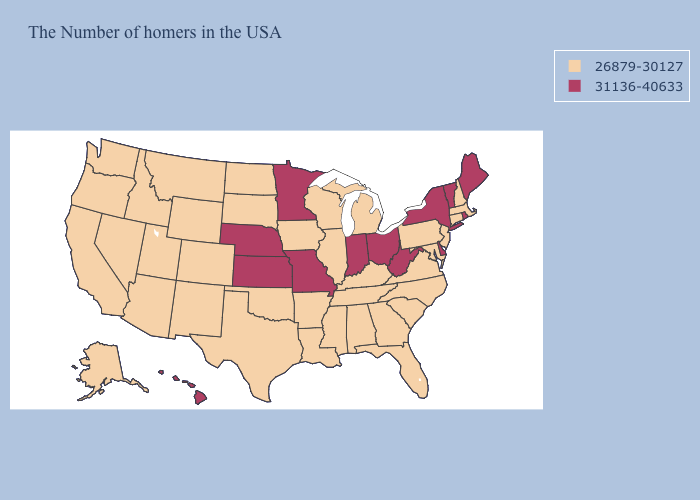Which states have the lowest value in the USA?
Be succinct. Massachusetts, New Hampshire, Connecticut, New Jersey, Maryland, Pennsylvania, Virginia, North Carolina, South Carolina, Florida, Georgia, Michigan, Kentucky, Alabama, Tennessee, Wisconsin, Illinois, Mississippi, Louisiana, Arkansas, Iowa, Oklahoma, Texas, South Dakota, North Dakota, Wyoming, Colorado, New Mexico, Utah, Montana, Arizona, Idaho, Nevada, California, Washington, Oregon, Alaska. What is the highest value in the MidWest ?
Write a very short answer. 31136-40633. Name the states that have a value in the range 31136-40633?
Give a very brief answer. Maine, Rhode Island, Vermont, New York, Delaware, West Virginia, Ohio, Indiana, Missouri, Minnesota, Kansas, Nebraska, Hawaii. What is the value of Indiana?
Short answer required. 31136-40633. What is the highest value in the USA?
Write a very short answer. 31136-40633. Does the map have missing data?
Concise answer only. No. Does Rhode Island have the lowest value in the Northeast?
Be succinct. No. What is the value of Wyoming?
Answer briefly. 26879-30127. Does Nebraska have a lower value than California?
Concise answer only. No. Name the states that have a value in the range 31136-40633?
Keep it brief. Maine, Rhode Island, Vermont, New York, Delaware, West Virginia, Ohio, Indiana, Missouri, Minnesota, Kansas, Nebraska, Hawaii. What is the value of Wyoming?
Keep it brief. 26879-30127. Which states have the lowest value in the South?
Concise answer only. Maryland, Virginia, North Carolina, South Carolina, Florida, Georgia, Kentucky, Alabama, Tennessee, Mississippi, Louisiana, Arkansas, Oklahoma, Texas. Does New York have the same value as New Mexico?
Concise answer only. No. 